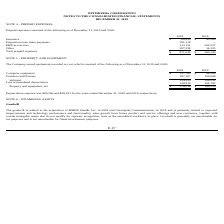According to Optimizerx Corporation's financial document, What was the depreciation expense in 2018? According to the financial document, $58,423. The relevant text states: "Depreciation expense was $80,206 and $58,423 for the years ended December 31, 2019 and 2018, respectively. NOTE 6 – INTANBIGLE ASSETS Goodwill Th..." Also, What were the net costs of property and equipment that the Company owned in 2018 and 2019, respectively? The document shows two values: $149,330 and $176,014. From the document: "Property and equipment, net $ 176,014 $ 149,330 Property and equipment, net $ 176,014 $ 149,330..." Also, What was the cost of computer equipment in 2018? According to the financial document, $94,384. The relevant text states: "Computer equipment $ 137,763 $ 94,384..." Also, can you calculate: What is the average subtotal cost of property and equipment that the Company owned from 2018 to 2019? To answer this question, I need to perform calculations using the financial data. The calculation is: (324,930+254,032)/2 , which equals 289481. This is based on the information: "Subtotal 324,930 254,032 Subtotal 324,930 254,032..." The key data points involved are: 254,032, 324,930. Also, can you calculate: What is the percentage change in the net cost of property and equipment from 2018 to 2019? To answer this question, I need to perform calculations using the financial data. The calculation is: (176,014-149,330)/149,330 , which equals 17.87 (percentage). This is based on the information: "Property and equipment, net $ 176,014 $ 149,330 Property and equipment, net $ 176,014 $ 149,330..." The key data points involved are: 149,330, 176,014. Also, can you calculate: What is the ratio of depreciation expense to accumulated depreciation of property and equipment in 2019? Based on the calculation: 80,206/148,916 , the result is 0.54. This is based on the information: "Less accumulated depreciation 148,916 104,702 Depreciation expense was $80,206 and $58,423 for the years ended December 31, 2019 and 2018, respectively. NOTE 6 – INTANBIGLE ASSET..." The key data points involved are: 148,916, 80,206. 